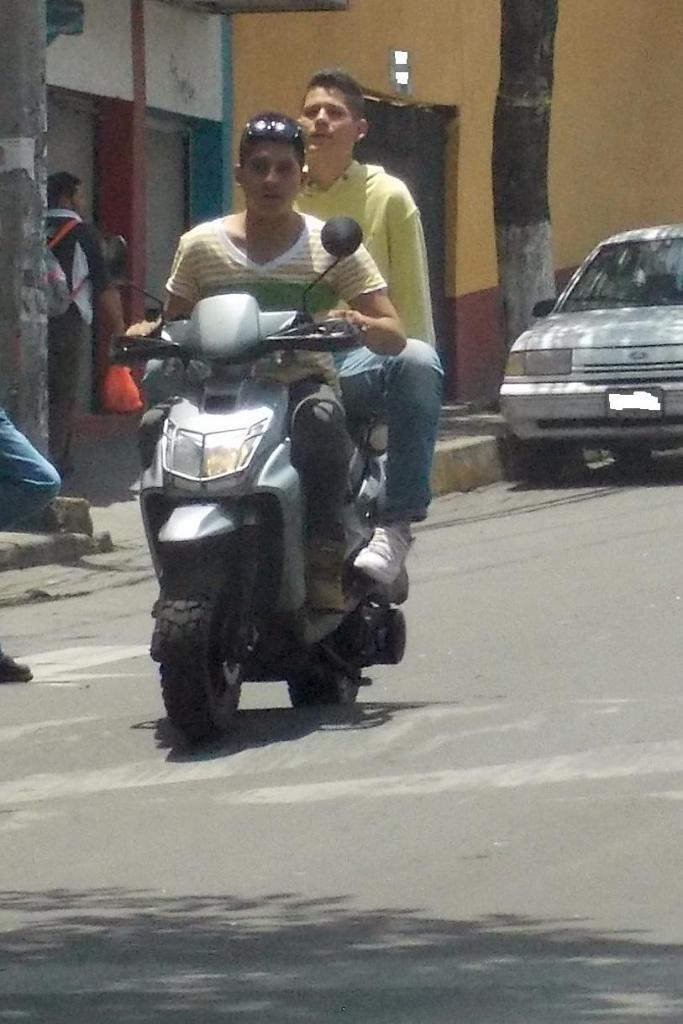What are the two men doing in the image? The two men are sitting on a motorbike and riding it. What can be seen on the road in the image? There is a car on the road in the image. What is present in the background of the image? There is a tree and a building in the image. What is the man wearing on his body? One man is wearing a bag. What is the man holding in his hand? The man is holding a plastic bag. Reasoning: Let'g: Let's think step by step in order to produce the conversation. We start by identifying the main action in the image, which is the two men riding the motorbike. Then, we expand the conversation to include other elements in the image, such as the car on the road, the tree and building in the background, and the man wearing and holding bags. Each question is designed to elicit a specific detail about the image that is known from the provided facts. Absurd Question/Answer: What type of fruit is hanging from the tree in the image? There is no fruit hanging from the tree in the image; only the tree itself is visible. 